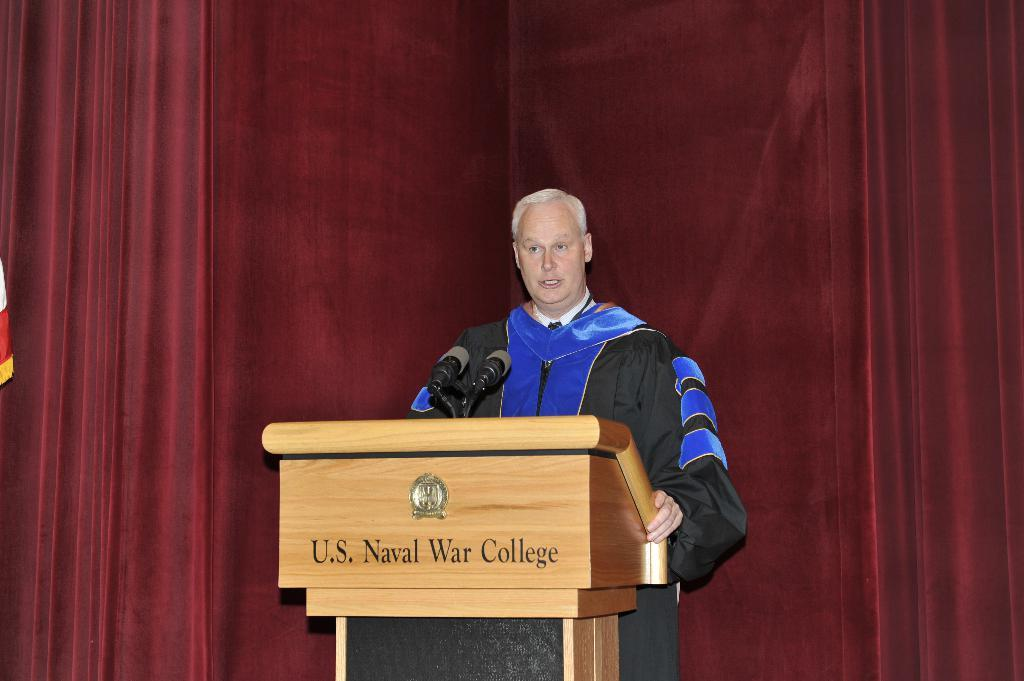What is the man in the image doing? The man is standing in front of the podium. Where is the man positioned in relation to the mikes? The man is standing near the mikes. What can be seen in the background of the image? There are curtains in the background of the image. What information might be available on the podium? There is text visible on the podium. What color is the orange on the desk in the image? There is no orange or desk present in the image. Is there a spot on the man's shirt in the image? The image does not provide enough detail to determine if there is a spot on the man's shirt. 